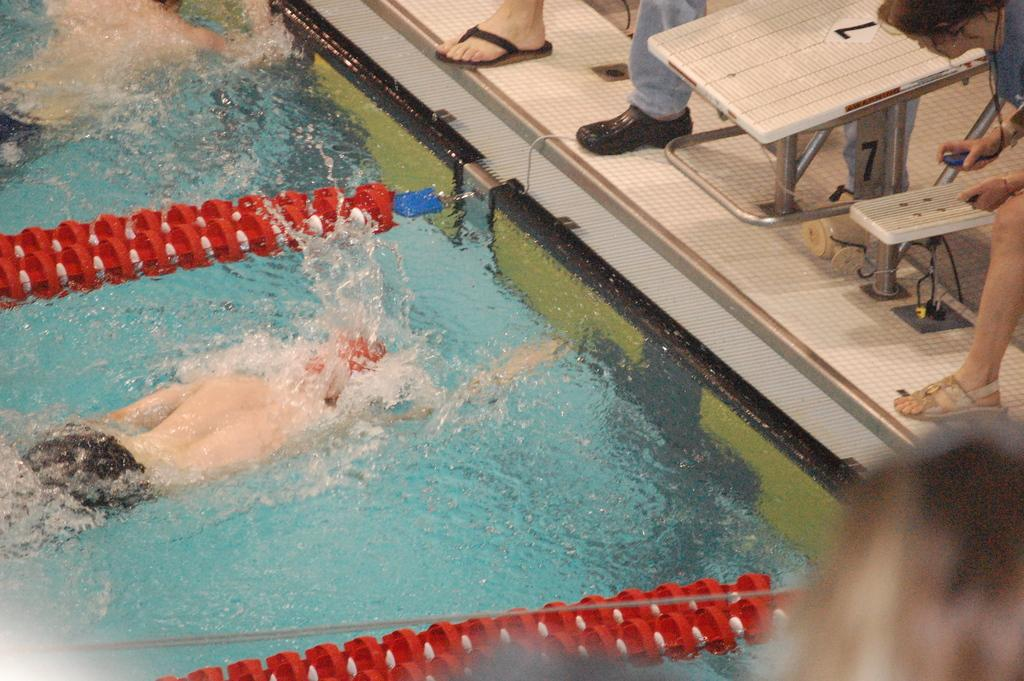What are the two people in the image doing? The two people in the image are swimming in the pool. Can you describe what is visible on the right side of the image? Human legs are visible on the right side of the image. What is the woman in the image holding? A woman is holding an object in the image. How many spiders are crawling on the woman's legs in the image? There are no spiders visible in the image; only human legs are mentioned. 